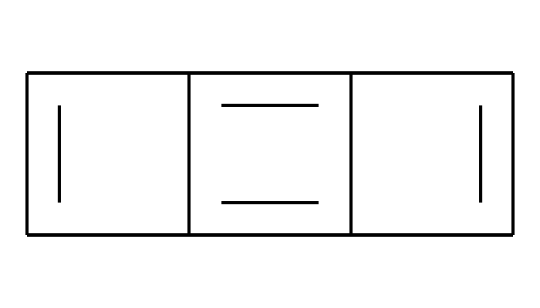What is the primary element present in the crystalline structure of this compound? The SMILES representation indicates that the only element present is carbon, as denoted by the letter 'C.'
Answer: carbon How many carbon atoms are present in the structure? By analyzing the SMILES notation, we count a total of 12 carbons represented by the letter 'C' which is repeated.
Answer: 12 What type of structure does this chemical represent? The arrangement in the SMILES notation reflects a planar, layered structure characteristic of graphite.
Answer: layered Does this compound have aromatic properties? The repeating double bonds in the chemical structure demonstrate resonance, identifying it as aromatic.
Answer: yes What is the main bonding characteristic observed in this chemical structure? The presence of numerous conjugated double bonds indicates that the main bonding characteristic is covalent bonding in a stable network.
Answer: covalent How does the crystalline structure affect the electrical conductivity of graphite? The presence of delocalized π electrons within the layers allows for electrical conductivity, which is a result of the structure’s resonance.
Answer: delocalized electrons What is the typical application of this compound due to its structural properties? The layered, robust nature of the graphite structure makes it ideal for applications in tennis racket frames, providing strength and lightweight characteristics.
Answer: tennis rackets 